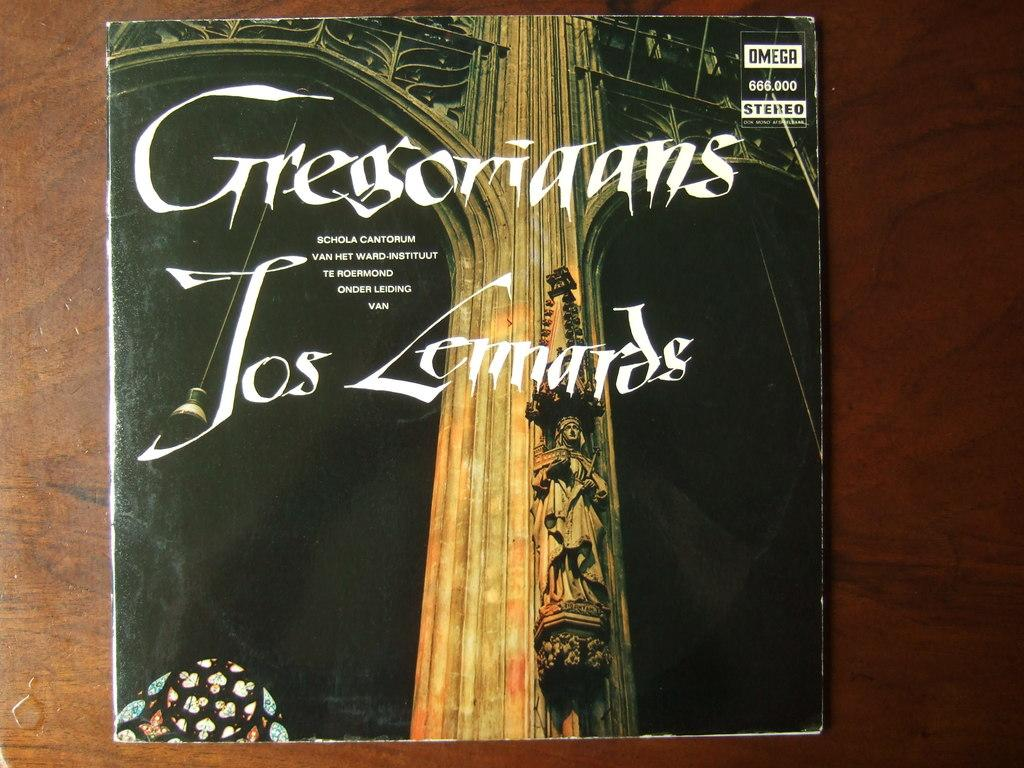<image>
Present a compact description of the photo's key features. An album featuring a large column on the cover is in OMEGA stereo. 